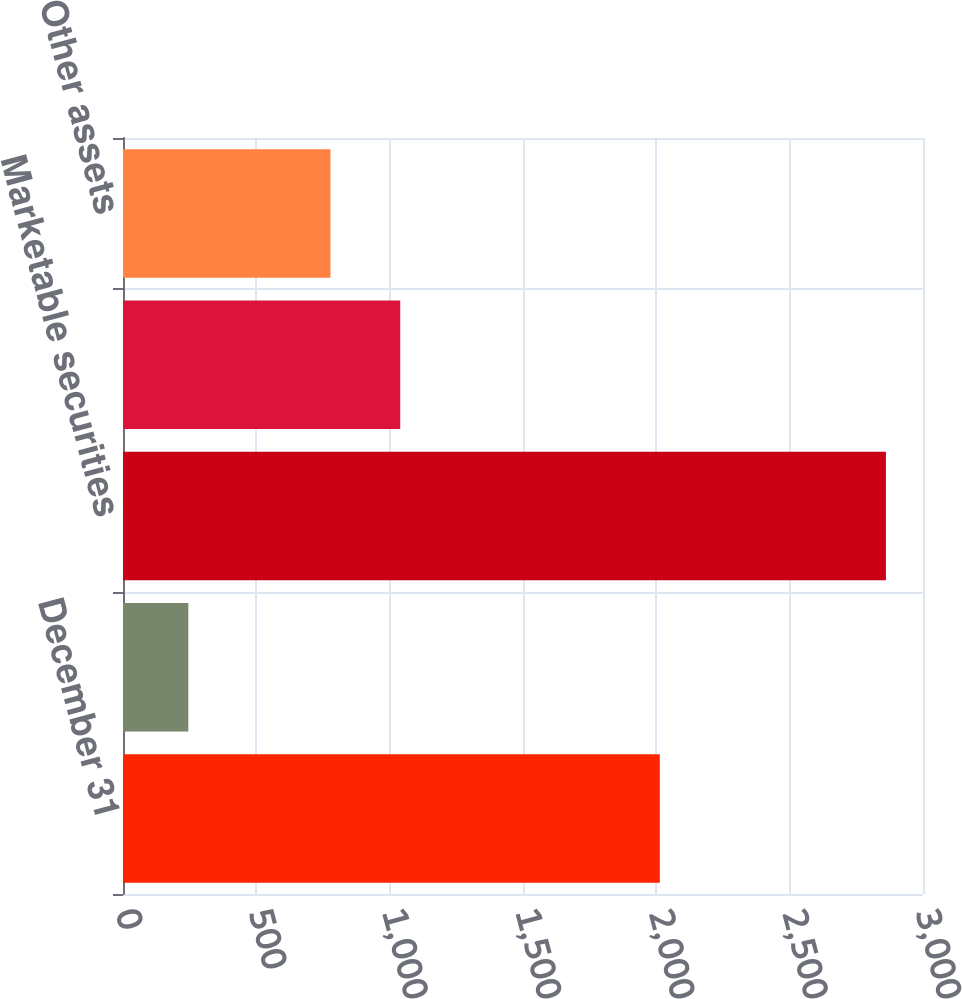Convert chart to OTSL. <chart><loc_0><loc_0><loc_500><loc_500><bar_chart><fcel>December 31<fcel>Cash and cash equivalents<fcel>Marketable securities<fcel>Other investments principally<fcel>Other assets<nl><fcel>2013<fcel>245<fcel>2861<fcel>1039.6<fcel>778<nl></chart> 